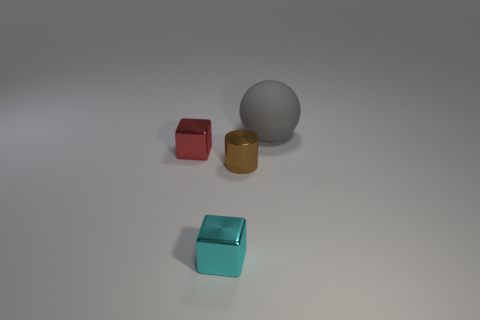What number of other metal objects are the same shape as the cyan shiny thing?
Ensure brevity in your answer.  1. Do the brown thing and the metal object that is behind the metal cylinder have the same shape?
Offer a terse response. No. Is there another large thing that has the same material as the brown object?
Give a very brief answer. No. Is there any other thing that has the same material as the red block?
Give a very brief answer. Yes. There is a small block in front of the metallic thing that is behind the brown metallic thing; what is it made of?
Offer a terse response. Metal. There is a block in front of the small metallic object left of the tiny object that is in front of the brown cylinder; what size is it?
Offer a terse response. Small. How many other objects are there of the same shape as the rubber object?
Make the answer very short. 0. Does the thing on the right side of the tiny brown shiny object have the same color as the cube that is on the left side of the cyan metallic block?
Ensure brevity in your answer.  No. There is a metallic cylinder that is the same size as the red object; what is its color?
Give a very brief answer. Brown. Are there any rubber spheres of the same color as the rubber thing?
Ensure brevity in your answer.  No. 